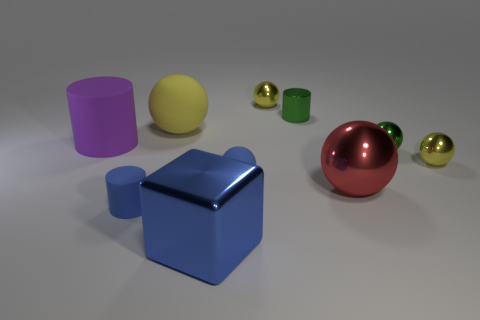Subtract all purple matte cylinders. How many cylinders are left? 2 Subtract all blue spheres. How many spheres are left? 5 Subtract all purple cubes. How many yellow spheres are left? 3 Subtract all cubes. How many objects are left? 9 Subtract 2 spheres. How many spheres are left? 4 Add 7 big cylinders. How many big cylinders are left? 8 Add 8 yellow shiny cubes. How many yellow shiny cubes exist? 8 Subtract 0 purple blocks. How many objects are left? 10 Subtract all purple blocks. Subtract all gray spheres. How many blocks are left? 1 Subtract all large yellow things. Subtract all large blue things. How many objects are left? 8 